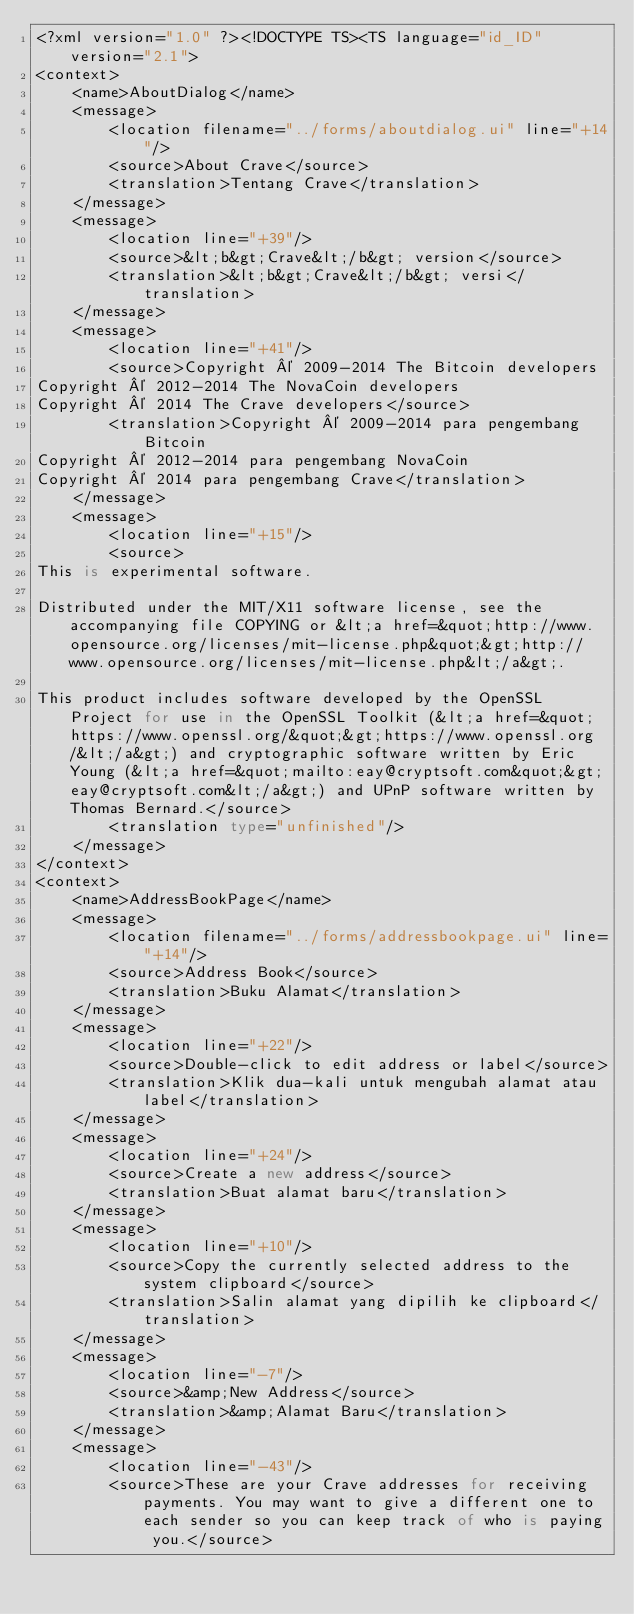<code> <loc_0><loc_0><loc_500><loc_500><_TypeScript_><?xml version="1.0" ?><!DOCTYPE TS><TS language="id_ID" version="2.1">
<context>
    <name>AboutDialog</name>
    <message>
        <location filename="../forms/aboutdialog.ui" line="+14"/>
        <source>About Crave</source>
        <translation>Tentang Crave</translation>
    </message>
    <message>
        <location line="+39"/>
        <source>&lt;b&gt;Crave&lt;/b&gt; version</source>
        <translation>&lt;b&gt;Crave&lt;/b&gt; versi</translation>
    </message>
    <message>
        <location line="+41"/>
        <source>Copyright © 2009-2014 The Bitcoin developers
Copyright © 2012-2014 The NovaCoin developers
Copyright © 2014 The Crave developers</source>
        <translation>Copyright © 2009-2014 para pengembang Bitcoin
Copyright © 2012-2014 para pengembang NovaCoin
Copyright © 2014 para pengembang Crave</translation>
    </message>
    <message>
        <location line="+15"/>
        <source>
This is experimental software.

Distributed under the MIT/X11 software license, see the accompanying file COPYING or &lt;a href=&quot;http://www.opensource.org/licenses/mit-license.php&quot;&gt;http://www.opensource.org/licenses/mit-license.php&lt;/a&gt;.

This product includes software developed by the OpenSSL Project for use in the OpenSSL Toolkit (&lt;a href=&quot;https://www.openssl.org/&quot;&gt;https://www.openssl.org/&lt;/a&gt;) and cryptographic software written by Eric Young (&lt;a href=&quot;mailto:eay@cryptsoft.com&quot;&gt;eay@cryptsoft.com&lt;/a&gt;) and UPnP software written by Thomas Bernard.</source>
        <translation type="unfinished"/>
    </message>
</context>
<context>
    <name>AddressBookPage</name>
    <message>
        <location filename="../forms/addressbookpage.ui" line="+14"/>
        <source>Address Book</source>
        <translation>Buku Alamat</translation>
    </message>
    <message>
        <location line="+22"/>
        <source>Double-click to edit address or label</source>
        <translation>Klik dua-kali untuk mengubah alamat atau label</translation>
    </message>
    <message>
        <location line="+24"/>
        <source>Create a new address</source>
        <translation>Buat alamat baru</translation>
    </message>
    <message>
        <location line="+10"/>
        <source>Copy the currently selected address to the system clipboard</source>
        <translation>Salin alamat yang dipilih ke clipboard</translation>
    </message>
    <message>
        <location line="-7"/>
        <source>&amp;New Address</source>
        <translation>&amp;Alamat Baru</translation>
    </message>
    <message>
        <location line="-43"/>
        <source>These are your Crave addresses for receiving payments. You may want to give a different one to each sender so you can keep track of who is paying you.</source></code> 